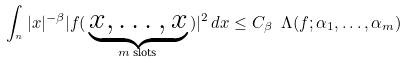<formula> <loc_0><loc_0><loc_500><loc_500>\int _ { \real ^ { n } } | x | ^ { - \beta } | f ( \, \underbrace { x , \dots , x } _ { \text {$m$ slots} } \, ) | ^ { 2 } \, d x \leq C _ { \beta } \ \Lambda ( f ; \alpha _ { 1 } , \dots , \alpha _ { m } )</formula> 